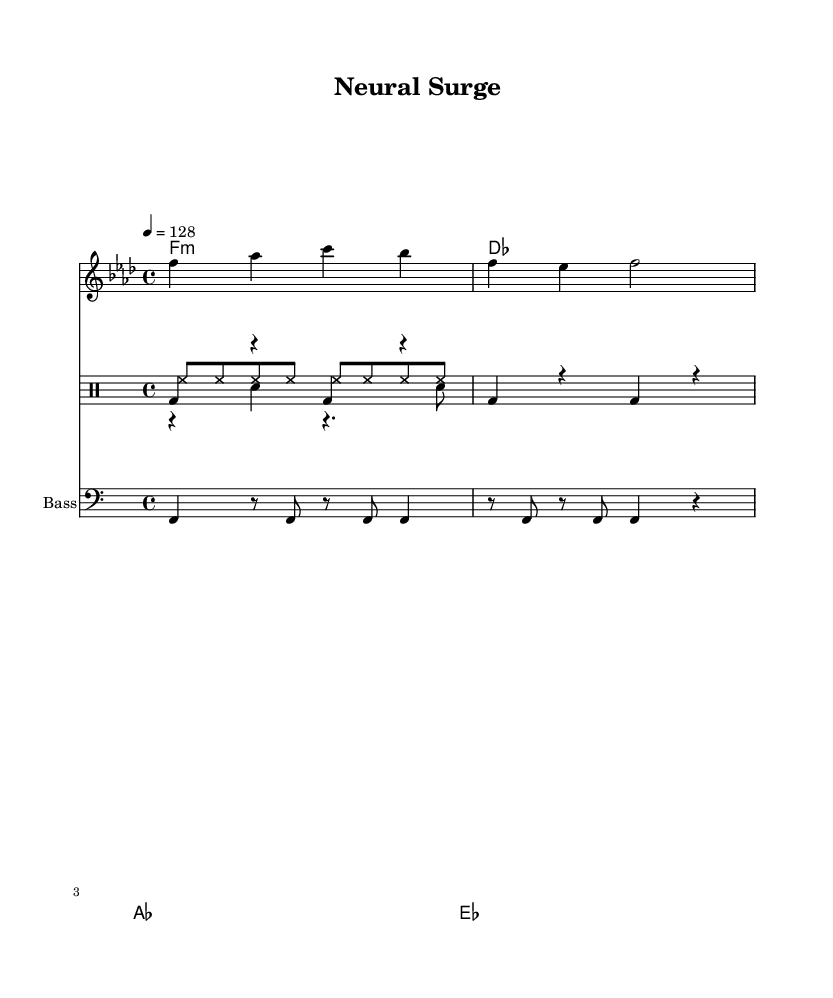What is the key signature of this music? The key signature is indicated near the beginning of the score. In the case of "Neural Surge," it is marked as F minor, which has four flats (B, E, A, D).
Answer: F minor What is the time signature of this piece? The time signature is shown at the start of the score, specifying how many beats are in each measure and which note value is held for one beat. Here, it shows 4/4, meaning there are four beats in a measure and the quarter note gets one beat.
Answer: 4/4 What is the tempo marking provided in the music? The tempo marking appears at the top of the score and indicates how fast the piece should be played. It is given as "4 = 128," meaning that a quarter note should be played at a speed of 128 beats per minute.
Answer: 128 How many measures are in the main theme? To determine this, you can count the number of complete sequences of notes within the mainTheme. The mainTheme contains two measures as represented by the notation shown.
Answer: 2 What type of drums are used in the kick pattern? The kick pattern uses a bass drum, which is typically denoted by "bd" in drummode notation. The notation shows repeated bass drum hits over a specific rhythmic pattern.
Answer: Bass What instrument is indicated for the bass drop pattern? The bass drop pattern specifies which instrument plays by having "Bass" set as the instrument name. This is distinct from other voices, highlighting its role in the electronic music genre.
Answer: Bass What is the function of the hi-hat in this piece? The hi-hat is represented in the drummode notation as "hh," indicating which percussion instrument is used. It plays consistently throughout the measures, maintaining rhythmic continuity typical in electronic music.
Answer: Hi-hat 